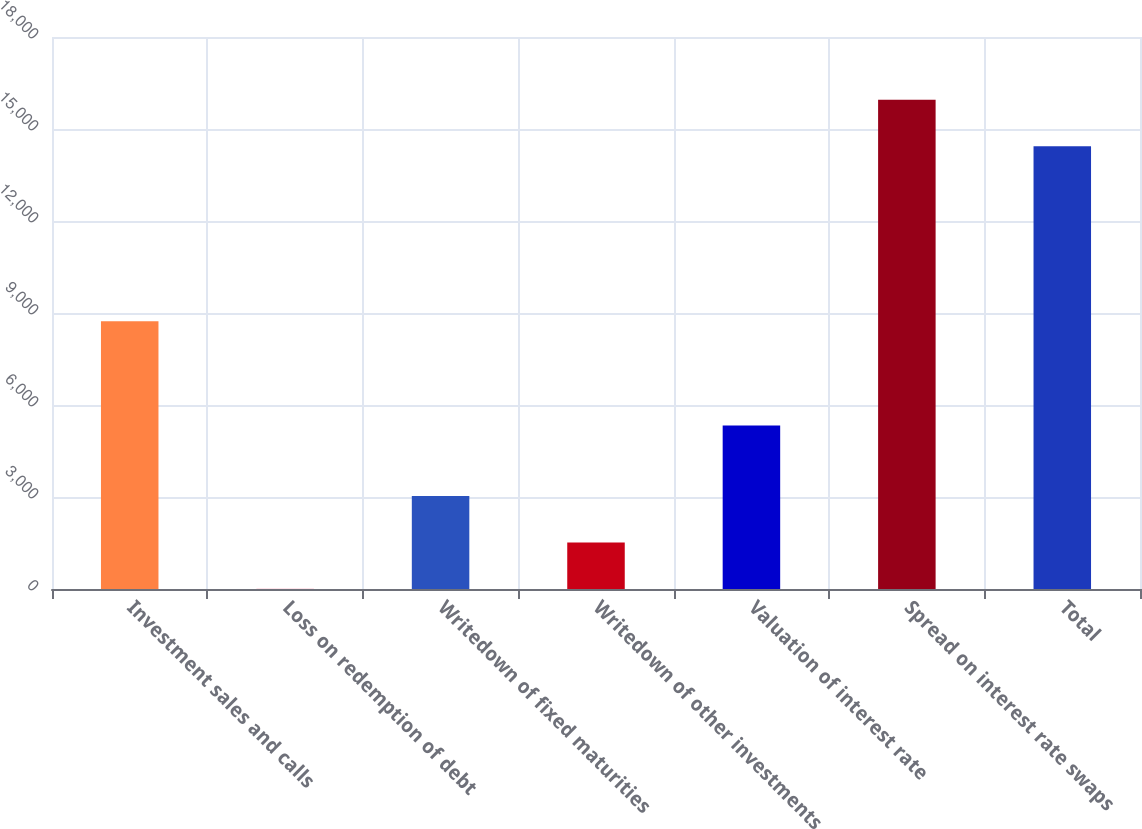Convert chart to OTSL. <chart><loc_0><loc_0><loc_500><loc_500><bar_chart><fcel>Investment sales and calls<fcel>Loss on redemption of debt<fcel>Writedown of fixed maturities<fcel>Writedown of other investments<fcel>Valuation of interest rate<fcel>Spread on interest rate swaps<fcel>Total<nl><fcel>8734<fcel>4.5<fcel>3035<fcel>1519.75<fcel>5332<fcel>15955.2<fcel>14440<nl></chart> 